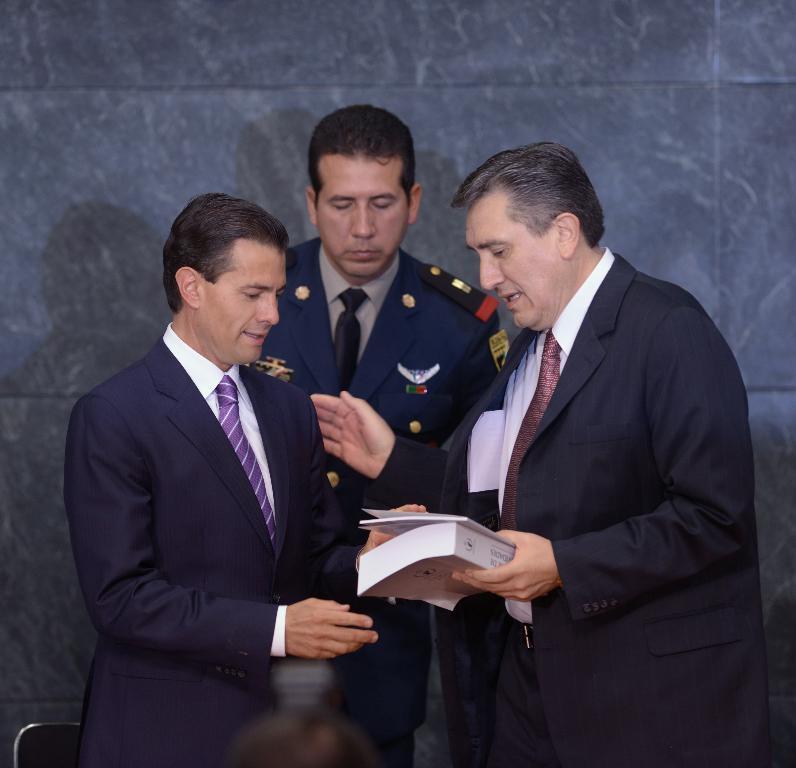Can you describe this image briefly? Here in this picture we can see three persons standing over a place and all of them are wearing suits on them and the person on the right side is carrying books in his hands and speaking something to the person beside him over there. 